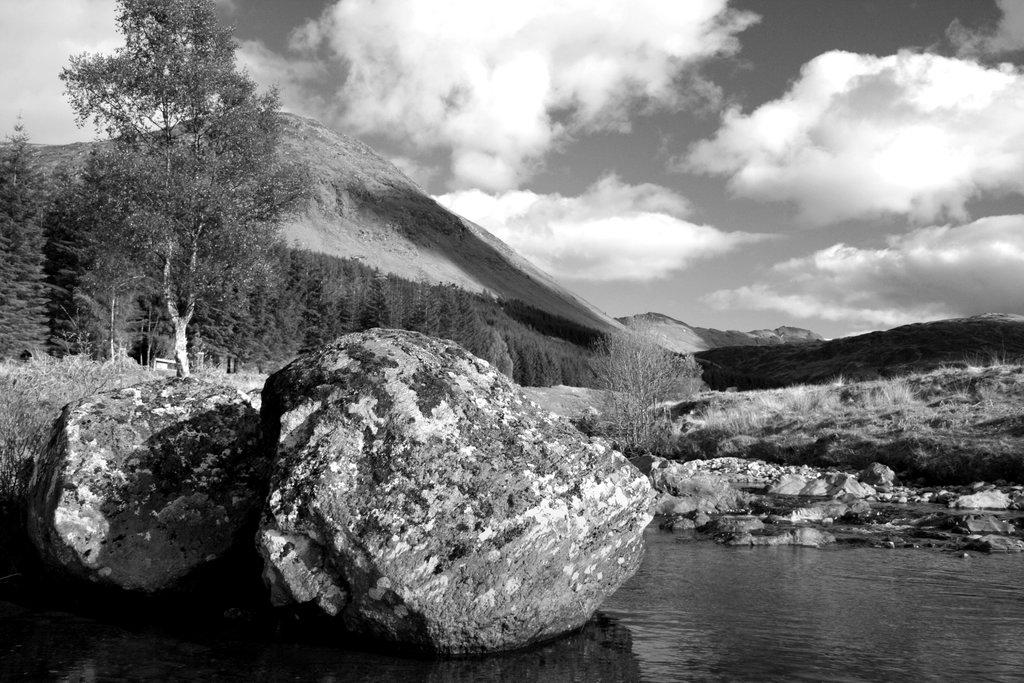What type of natural elements can be seen in the image? There are rocks, water, trees, and mountains visible in the image. What is the color scheme of the image? The image is in black and white. What part of the sky is visible in the image? The sky is visible in the image. How many fish can be seen swimming in the water in the image? There are no fish visible in the image, as it is in black and white and does not depict any aquatic life. Is there a bathtub present in the image? There is no bathtub present in the image; it features natural elements such as rocks, water, trees, and mountains. 